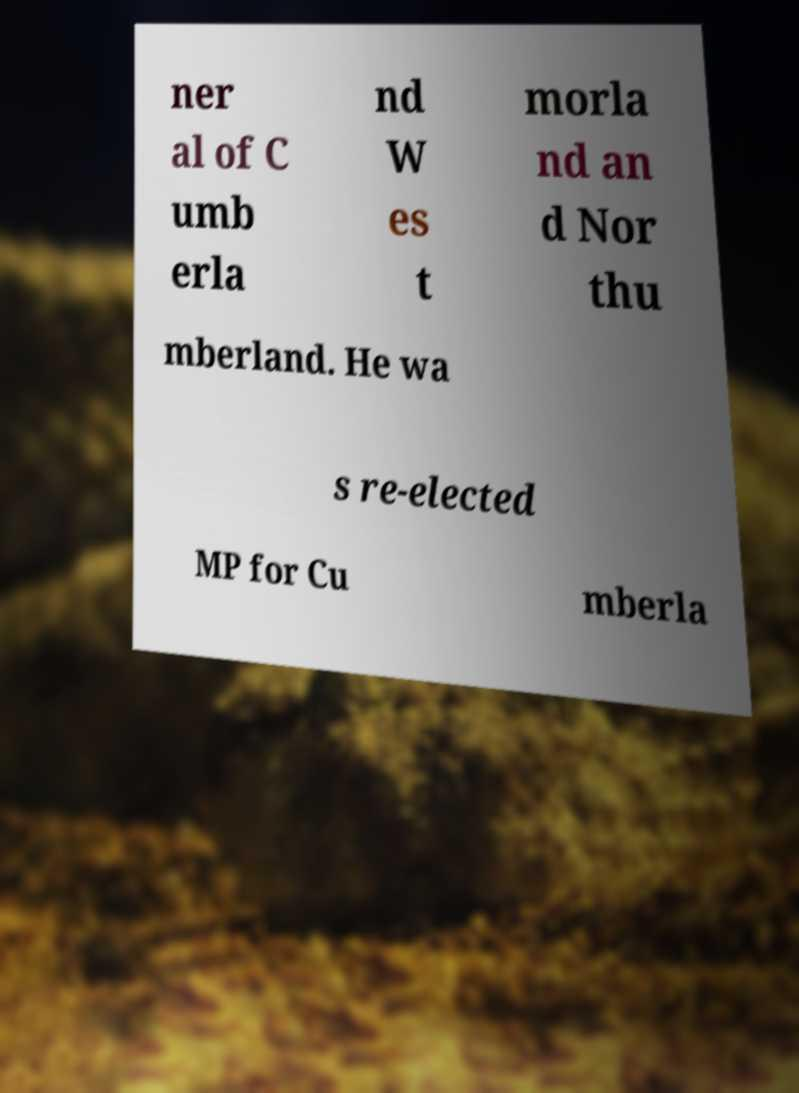Can you accurately transcribe the text from the provided image for me? ner al of C umb erla nd W es t morla nd an d Nor thu mberland. He wa s re-elected MP for Cu mberla 